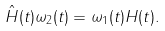Convert formula to latex. <formula><loc_0><loc_0><loc_500><loc_500>\hat { H } ( t ) \omega _ { 2 } ( t ) = \omega _ { 1 } ( t ) H ( t ) .</formula> 